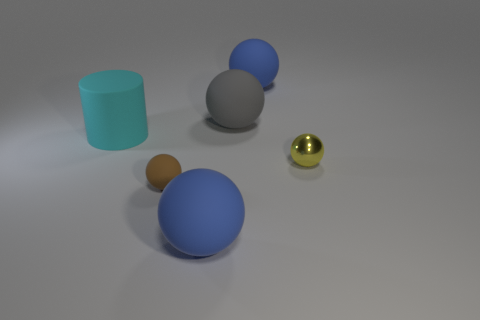Subtract all yellow balls. How many balls are left? 4 Subtract all brown spheres. How many spheres are left? 4 Subtract 2 balls. How many balls are left? 3 Subtract all gray spheres. Subtract all cyan blocks. How many spheres are left? 4 Add 3 red metallic cubes. How many objects exist? 9 Subtract all cylinders. How many objects are left? 5 Add 3 big gray rubber balls. How many big gray rubber balls are left? 4 Add 3 brown objects. How many brown objects exist? 4 Subtract 0 purple spheres. How many objects are left? 6 Subtract all large cyan matte objects. Subtract all cylinders. How many objects are left? 4 